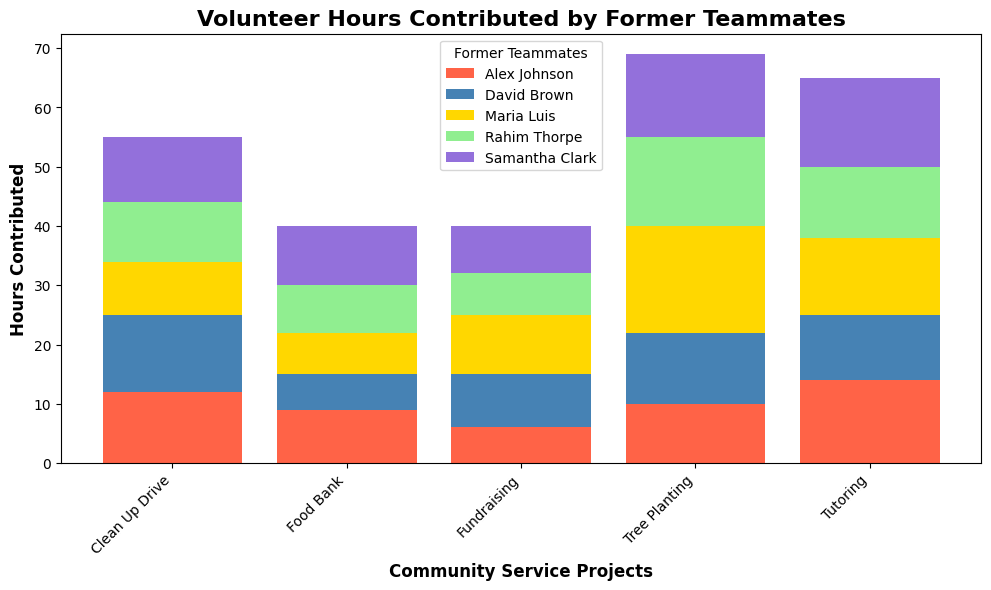Who contributed the most hours in total across all projects? Calculate the total hours each former teammate contributed by summing their hours across all projects. Compare the totals; Rahim Thorpe: 15+10+8+12+7=52, Alex Johnson: 10+12+9+14+6=51, Maria Luis: 18+9+7+13+10=57, Samantha Clark: 14+11+10+15+8=58, David Brown: 12+13+6+11+9=51. Samantha Clark has the highest total of 58 hours.
Answer: Samantha Clark Which project had the highest total volunteer hours contributed? Sum the volunteer hours for each project across all teammates and compare the totals; Tree Planting: 15+10+18+14+12=69, Clean Up Drive: 10+12+9+11+13=55, Food Bank: 8+9+7+10+6=40, Tutoring: 12+14+13+15+11=65, Fundraising: 7+6+10+8+9=40. Tree Planting has the highest total at 69 hours.
Answer: Tree Planting Did Rahim Thorpe contribute more hours to Tree Planting or Tutoring? Compare Rahim Thorpe's hours for Tree Planting (15) and Tutoring (12). Tree Planting has more hours.
Answer: Tree Planting How many more hours did Samantha Clark contribute to Tutoring compared to Rahim Thorpe? Subtract Rahim Thorpe's hours for Tutoring (12) from Samantha Clark's hours for Tutoring (15), i.e., 15-12=3. Samantha Clark contributed 3 more hours.
Answer: 3 Who contributed the least hours to the Food Bank project? Compare the volunteer hours contributed to the Food Bank project by each former teammate: Rahim Thorpe (8), Alex Johnson (9), Maria Luis (7), Samantha Clark (10), David Brown (6). David Brown contributed the least with 6 hours.
Answer: David Brown What is the average number of hours contributed to Fundraising by all former teammates? Sum the total hours for Fundraising by all teammates and divide by the number of teammates; total hours: 7+6+10+8+9=40, number of teammates: 5. The average is 40/5=8.
Answer: 8 What is the combined total of hours contributed by Alex Johnson and Maria Luis for the Tutoring project? Sum Alex Johnson's (14) and Maria Luis's (13) contributions to the Tutoring project; 14+13=27.
Answer: 27 Which former teammate had more consistent hours across all projects, Alex Johnson or David Brown? Calculate the range of hours for each former teammate by subtracting their lowest contribution from their highest. Alex Johnson: highest (14), lowest (6), range=14-6=8. David Brown: highest (13), lowest (6), range=13-6=7. David Brown has a smaller range, indicating more consistent hours.
Answer: David Brown Which project had the most variation in hours contributed by different former teammates? Calculate the range (max-min) for each project to find the variation; Tree Planting: range=18-10=8, Clean Up Drive: range=13-9=4, Food Bank: range=10-6=4, Tutoring: range=15-11=4, Fundraising: range=10-6=4. Tree Planting project has the highest variation with a range of 8 hours.
Answer: Tree Planting 